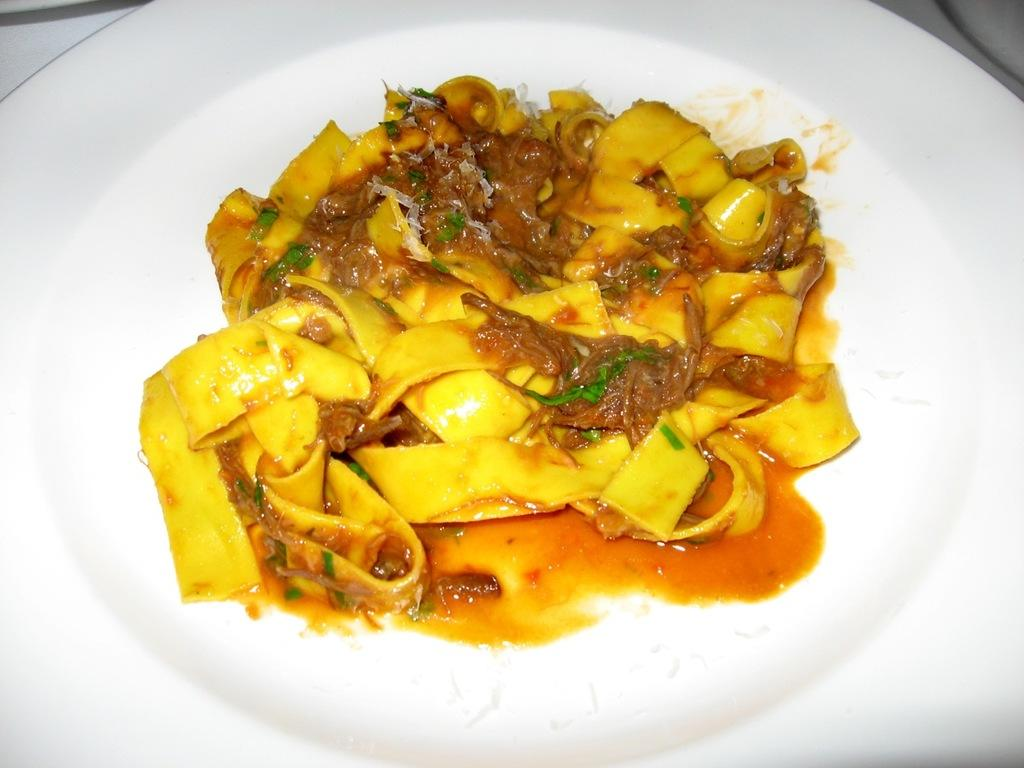What is the main subject of the image? There is a food item in the image. How is the food item presented in the image? The food item is placed on a white color plate. Where is the plate located in the image? The plate is located in the middle of the image. How does the pig contribute to the food item in the image? There is no pig present in the image, so it cannot contribute to the food item. 